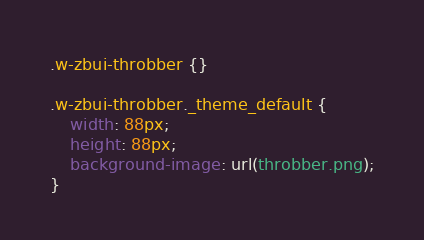<code> <loc_0><loc_0><loc_500><loc_500><_CSS_>.w-zbui-throbber {}

.w-zbui-throbber._theme_default {
	width: 88px;
	height: 88px;
	background-image: url(throbber.png);
}
</code> 